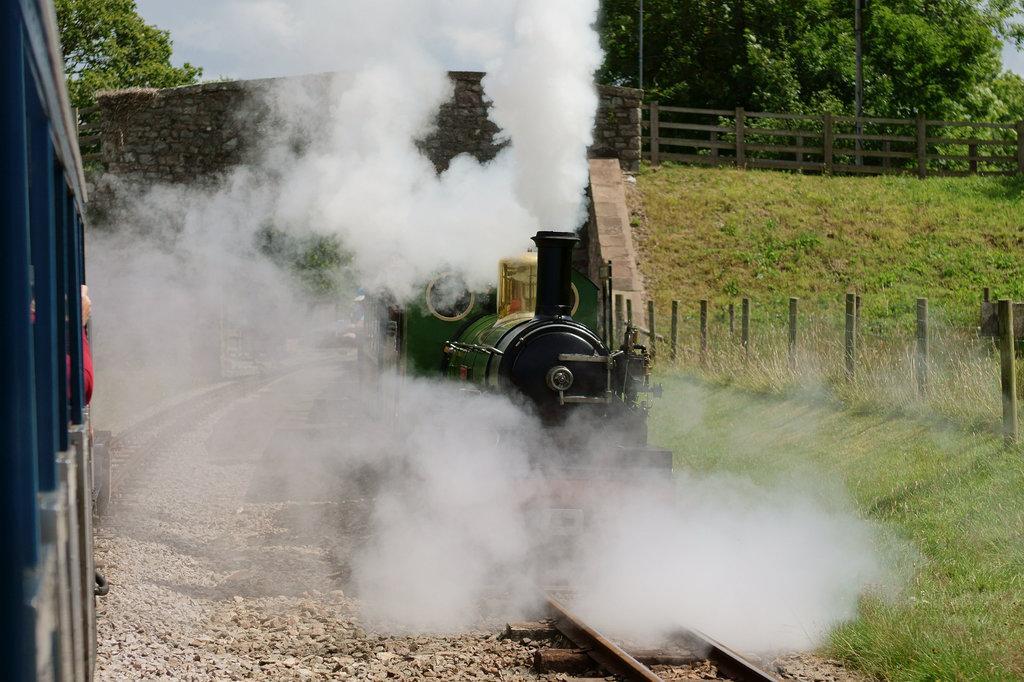How would you summarize this image in a sentence or two? In this image we can see trains. There are railway tracks. Also there are stones. Also there is smoke. On the ground there is grass. And there are poles. In the background there is a wall and a wooden fencing. Also there are trees and sky in the background. 